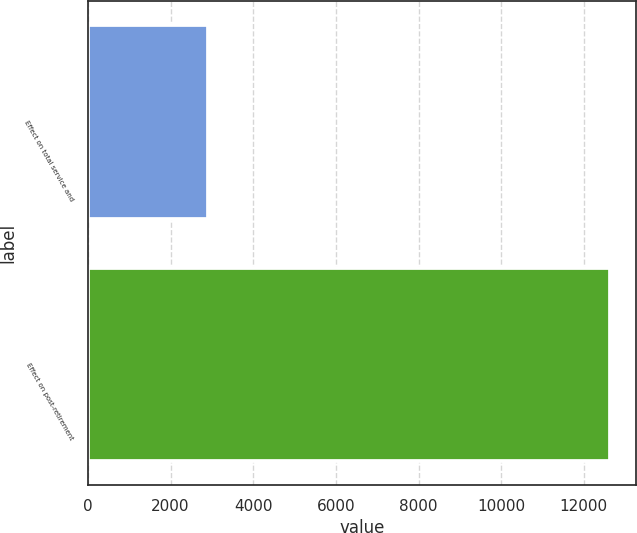Convert chart. <chart><loc_0><loc_0><loc_500><loc_500><bar_chart><fcel>Effect on total service and<fcel>Effect on post-retirement<nl><fcel>2896<fcel>12636<nl></chart> 